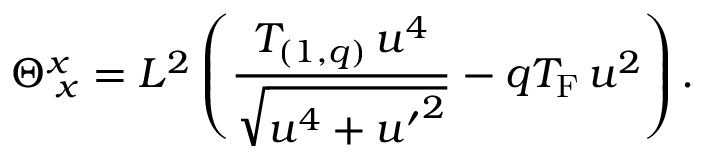Convert formula to latex. <formula><loc_0><loc_0><loc_500><loc_500>\Theta _ { \, x } ^ { x } = L ^ { 2 } \left ( { \frac { T _ { ( 1 , q ) } \, u ^ { 4 } } { \sqrt { u ^ { 4 } + { u ^ { \prime } } ^ { 2 } } } } - q T _ { F } \, u ^ { 2 } \right ) .</formula> 